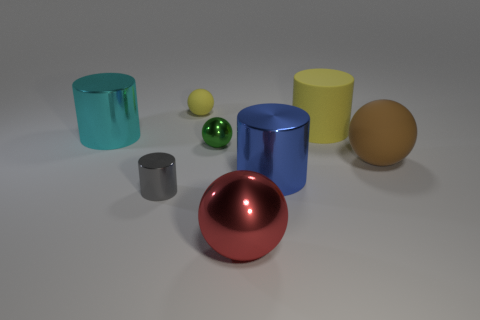There is a large object that is the same color as the small matte ball; what is its shape?
Offer a terse response. Cylinder. Are there any rubber balls that have the same color as the rubber cylinder?
Your answer should be compact. Yes. How many blue things are the same material as the green sphere?
Offer a terse response. 1. Is the number of tiny objects that are in front of the large red metal thing less than the number of gray metal cylinders that are in front of the tiny green object?
Give a very brief answer. Yes. The large sphere behind the tiny thing that is in front of the tiny metal object that is behind the large blue metal cylinder is made of what material?
Offer a terse response. Rubber. There is a ball that is both on the left side of the big blue cylinder and in front of the small green sphere; what is its size?
Your response must be concise. Large. What number of blocks are small yellow matte things or big yellow matte things?
Offer a very short reply. 0. What is the color of the shiny sphere that is the same size as the blue metallic object?
Offer a terse response. Red. What is the color of the other big rubber thing that is the same shape as the gray thing?
Your answer should be very brief. Yellow. What number of things are shiny things or large metal things in front of the green ball?
Offer a terse response. 5. 